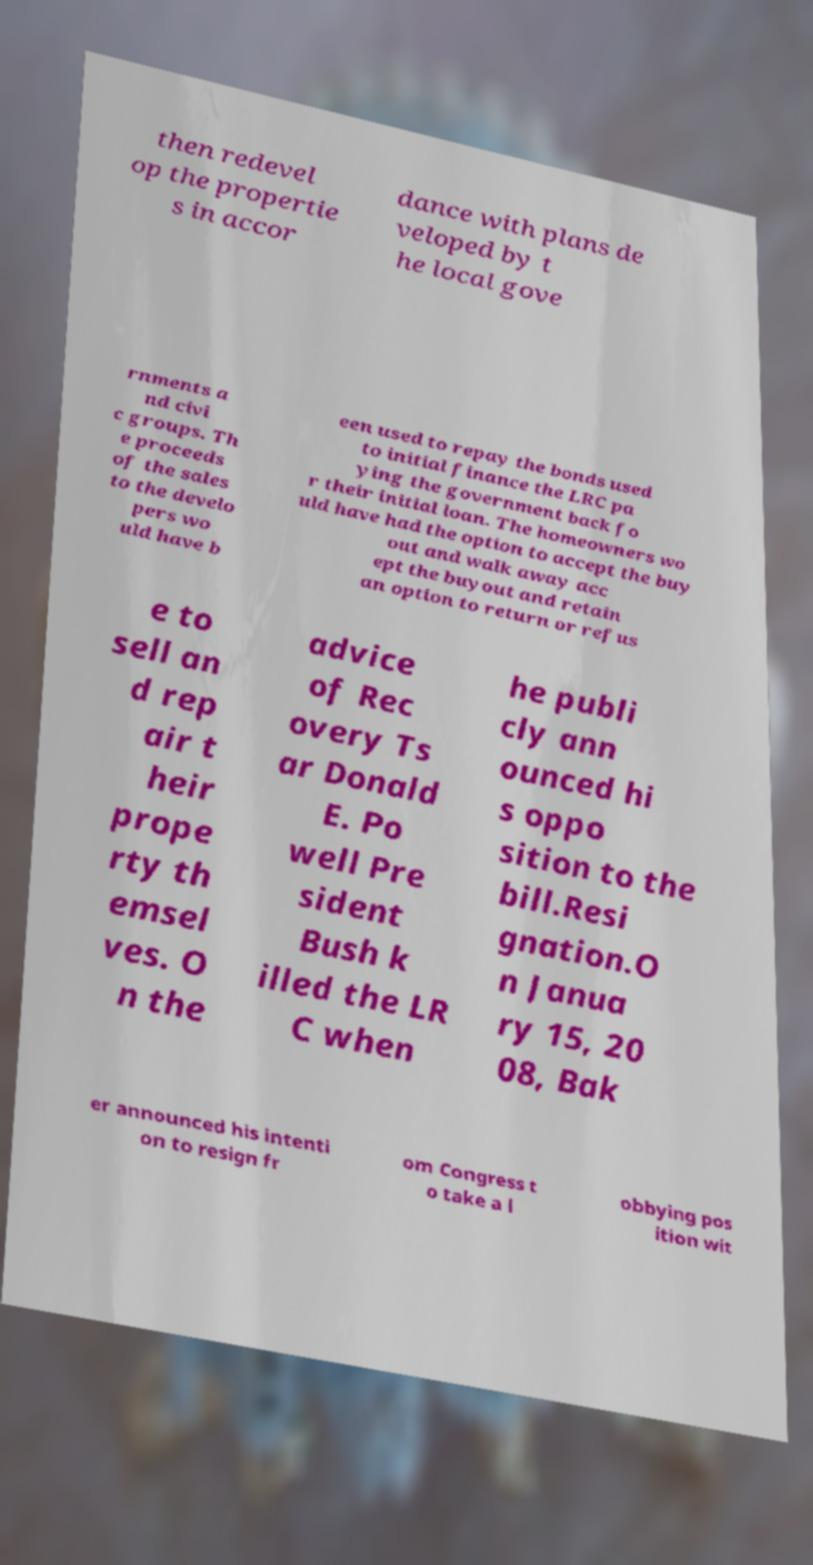For documentation purposes, I need the text within this image transcribed. Could you provide that? then redevel op the propertie s in accor dance with plans de veloped by t he local gove rnments a nd civi c groups. Th e proceeds of the sales to the develo pers wo uld have b een used to repay the bonds used to initial finance the LRC pa ying the government back fo r their initial loan. The homeowners wo uld have had the option to accept the buy out and walk away acc ept the buyout and retain an option to return or refus e to sell an d rep air t heir prope rty th emsel ves. O n the advice of Rec overy Ts ar Donald E. Po well Pre sident Bush k illed the LR C when he publi cly ann ounced hi s oppo sition to the bill.Resi gnation.O n Janua ry 15, 20 08, Bak er announced his intenti on to resign fr om Congress t o take a l obbying pos ition wit 